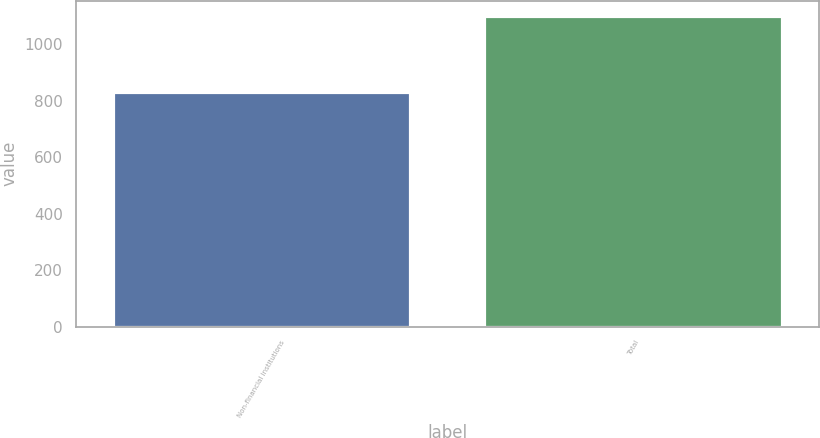<chart> <loc_0><loc_0><loc_500><loc_500><bar_chart><fcel>Non-financial institutions<fcel>Total<nl><fcel>830.9<fcel>1098.9<nl></chart> 